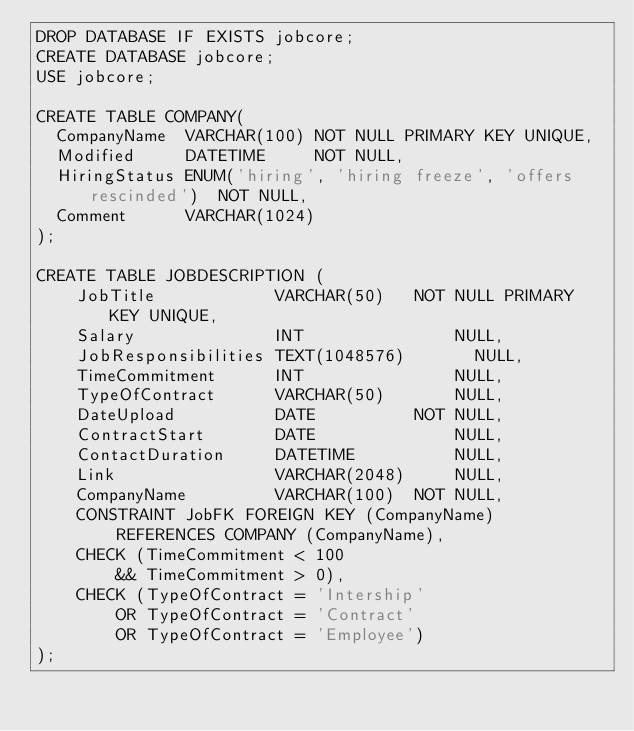Convert code to text. <code><loc_0><loc_0><loc_500><loc_500><_SQL_>DROP DATABASE IF EXISTS jobcore;
CREATE DATABASE jobcore;
USE jobcore;

CREATE TABLE COMPANY(
	CompanyName  VARCHAR(100) NOT NULL PRIMARY KEY UNIQUE,
	Modified     DATETIME     NOT NULL,
	HiringStatus ENUM('hiring', 'hiring freeze', 'offers rescinded')  NOT NULL,
	Comment      VARCHAR(1024)
);

CREATE TABLE JOBDESCRIPTION (
    JobTitle            VARCHAR(50)   NOT NULL PRIMARY KEY UNIQUE,
    Salary              INT               NULL,
    JobResponsibilities TEXT(1048576)       NULL,
    TimeCommitment      INT               NULL,
    TypeOfContract      VARCHAR(50)       NULL,
    DateUpload          DATE          NOT NULL,
    ContractStart       DATE              NULL,
    ContactDuration     DATETIME          NULL,
    Link                VARCHAR(2048)     NULL,
    CompanyName         VARCHAR(100)  NOT NULL,
    CONSTRAINT JobFK FOREIGN KEY (CompanyName)
        REFERENCES COMPANY (CompanyName),
    CHECK (TimeCommitment < 100
        && TimeCommitment > 0),
    CHECK (TypeOfContract = 'Intership'
        OR TypeOfContract = 'Contract'
        OR TypeOfContract = 'Employee')
);</code> 